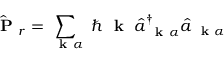<formula> <loc_0><loc_0><loc_500><loc_500>\hat { P } _ { r } = \sum _ { k \alpha } \, \hbar { k } \, \hat { a } _ { k \alpha } ^ { \dagger } \hat { a } _ { k \alpha }</formula> 